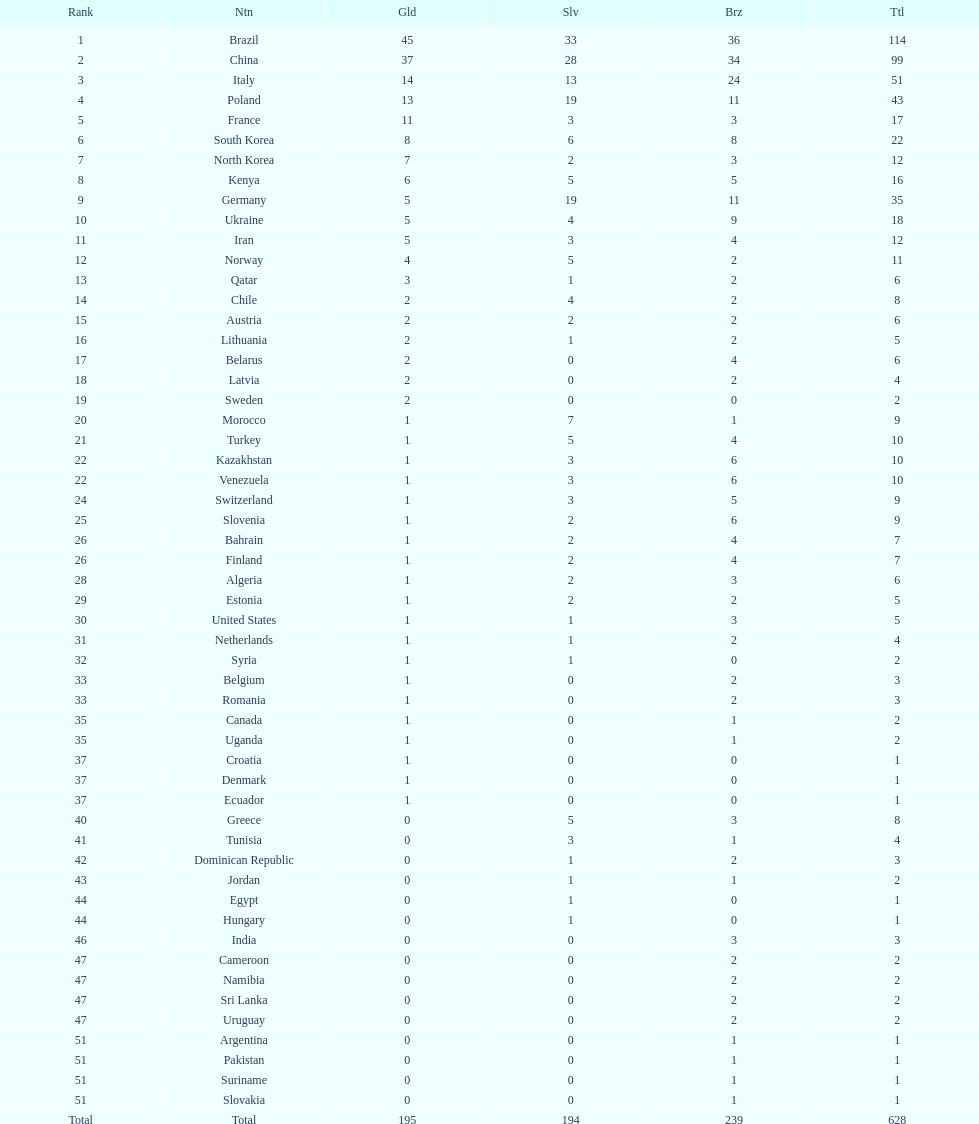How many gold medals did germany earn? 5. 